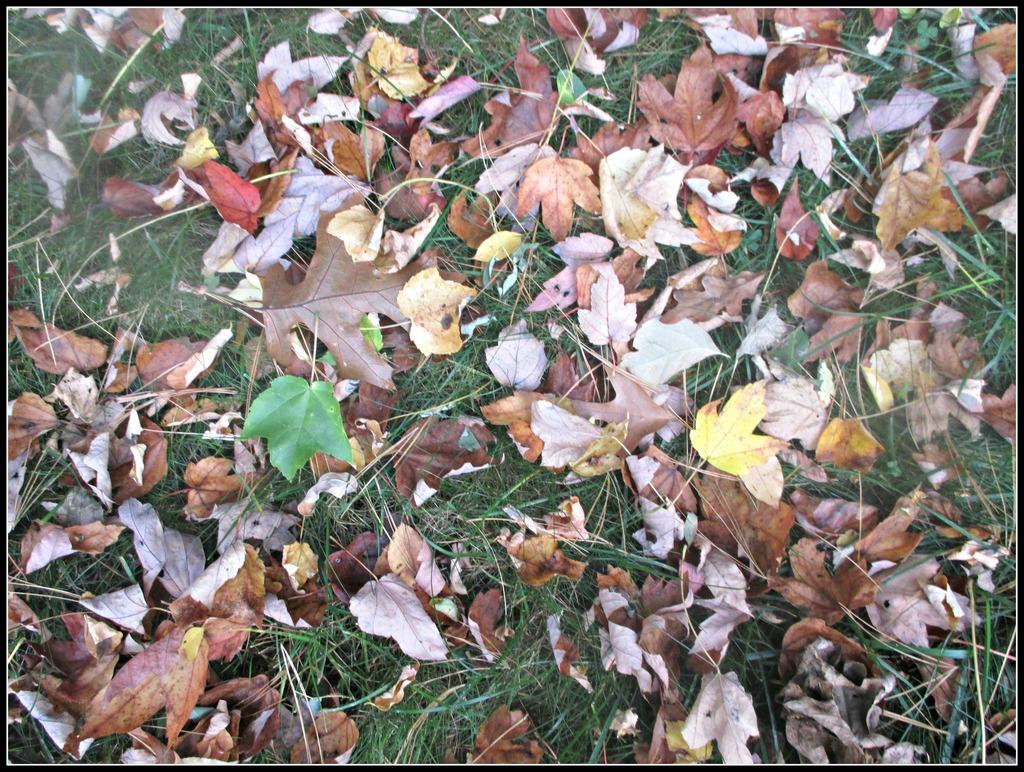What type of vegetation is visible in the image? There is grass in the image. Are there any additional features on the grass in the image? Yes, there are leaves on the grass in the image. Can you see a man smiling while holding a cub in the image? There is no man, smile, or cub present in the image; it only features grass and leaves. 